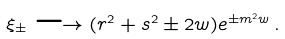<formula> <loc_0><loc_0><loc_500><loc_500>\xi _ { \pm } \longrightarrow ( r ^ { 2 } + s ^ { 2 } \pm 2 w ) e ^ { \pm m ^ { 2 } w } \, .</formula> 